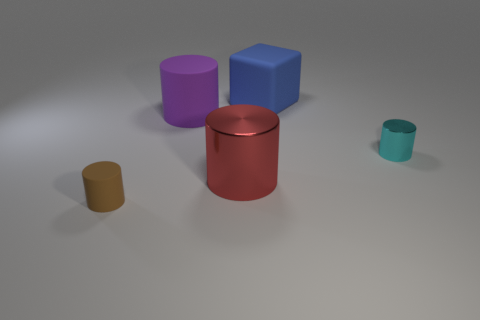Subtract all small cyan shiny cylinders. How many cylinders are left? 3 Subtract all brown cylinders. How many cylinders are left? 3 Add 1 small cyan rubber cylinders. How many objects exist? 6 Subtract 3 cylinders. How many cylinders are left? 1 Subtract all cylinders. How many objects are left? 1 Subtract all green balls. How many yellow cubes are left? 0 Subtract all tiny cylinders. Subtract all matte objects. How many objects are left? 0 Add 4 big red metallic things. How many big red metallic things are left? 5 Add 2 tiny brown rubber things. How many tiny brown rubber things exist? 3 Subtract 0 gray spheres. How many objects are left? 5 